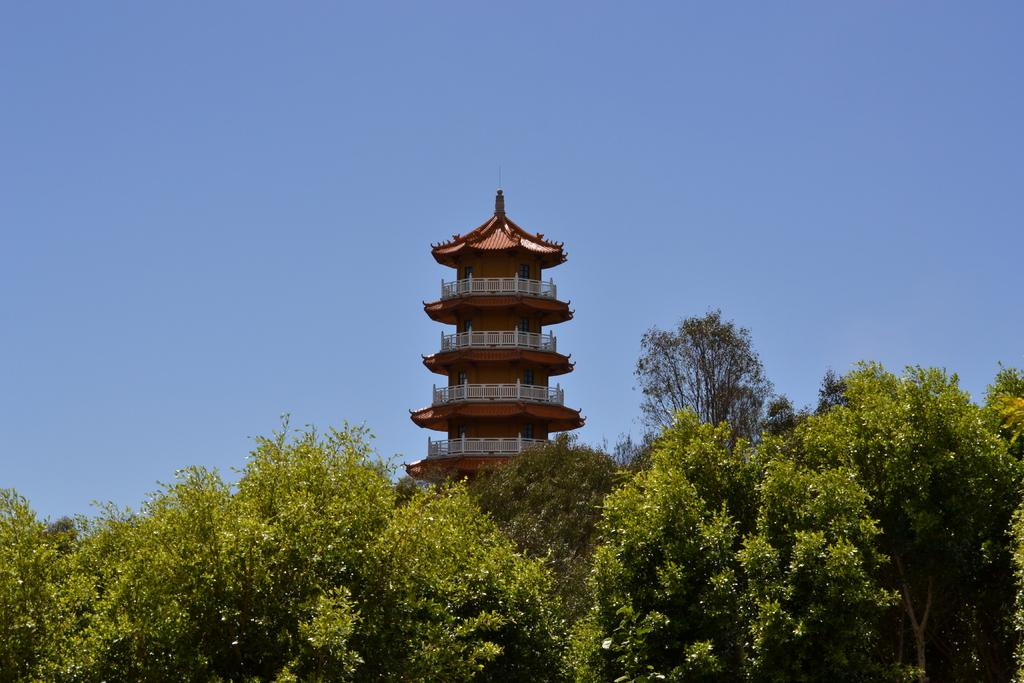What type of vegetation is at the bottom of the image? There are trees at the bottom of the image. What structure is located in the middle of the image? There is a building in the middle of the image. What feature of the building is mentioned in the facts? The building has windows. What type of barrier is present in the image? There are fences in the image. What part of the natural environment is visible in the image? The sky is visible in the image. What is the average income of the people living in the building in the image? The provided facts do not mention any information about the income of the people living in the building, so it cannot be determined from the image. What type of truck can be seen parked near the building in the image? There is no truck present in the image; only trees, a building, fences, and the sky are visible. 